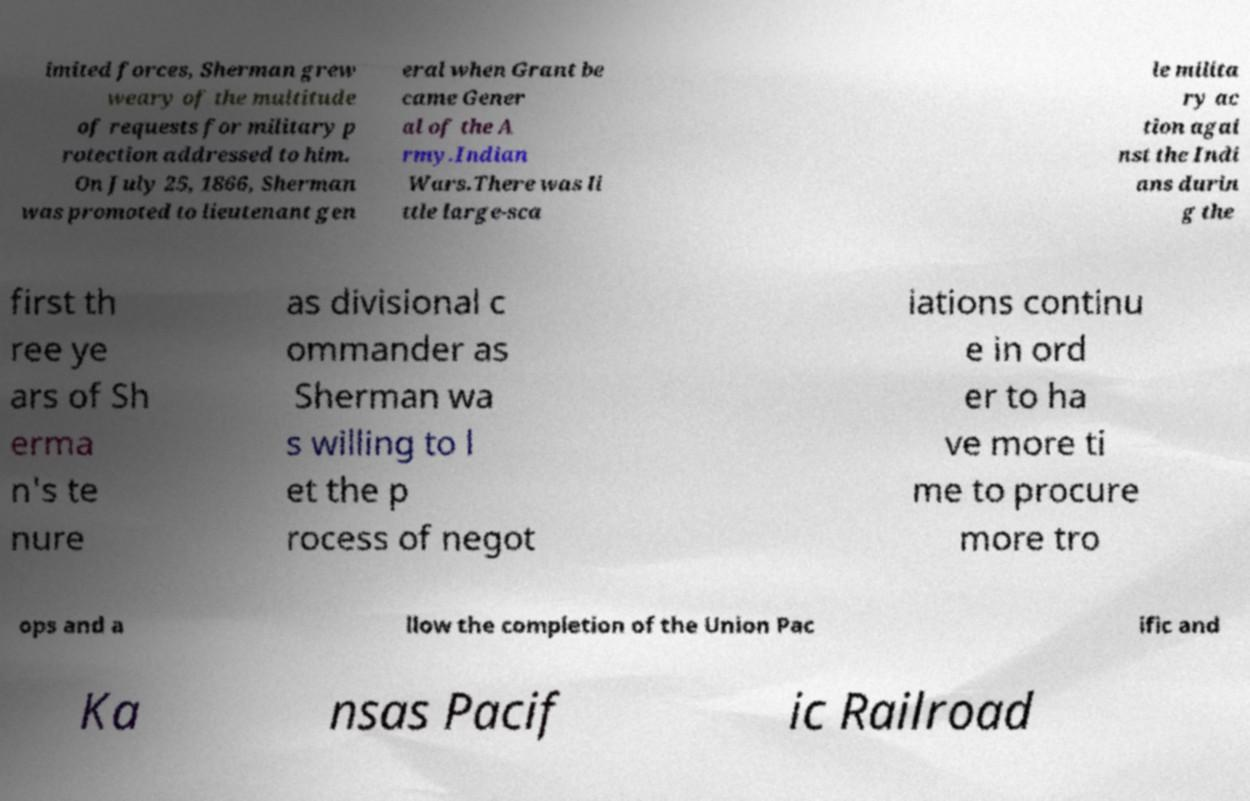There's text embedded in this image that I need extracted. Can you transcribe it verbatim? imited forces, Sherman grew weary of the multitude of requests for military p rotection addressed to him. On July 25, 1866, Sherman was promoted to lieutenant gen eral when Grant be came Gener al of the A rmy.Indian Wars.There was li ttle large-sca le milita ry ac tion agai nst the Indi ans durin g the first th ree ye ars of Sh erma n's te nure as divisional c ommander as Sherman wa s willing to l et the p rocess of negot iations continu e in ord er to ha ve more ti me to procure more tro ops and a llow the completion of the Union Pac ific and Ka nsas Pacif ic Railroad 